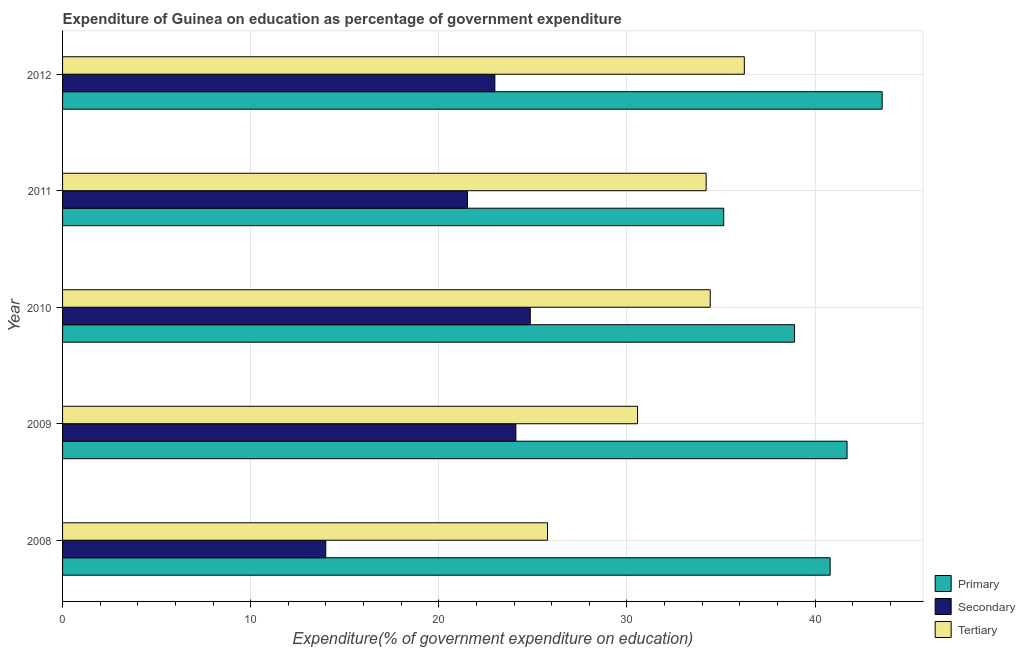Are the number of bars on each tick of the Y-axis equal?
Your response must be concise. Yes. How many bars are there on the 3rd tick from the top?
Keep it short and to the point. 3. How many bars are there on the 5th tick from the bottom?
Provide a succinct answer. 3. In how many cases, is the number of bars for a given year not equal to the number of legend labels?
Your answer should be very brief. 0. What is the expenditure on tertiary education in 2011?
Your response must be concise. 34.21. Across all years, what is the maximum expenditure on secondary education?
Your answer should be compact. 24.86. Across all years, what is the minimum expenditure on secondary education?
Provide a short and direct response. 13.99. In which year was the expenditure on primary education minimum?
Ensure brevity in your answer.  2011. What is the total expenditure on primary education in the graph?
Offer a terse response. 200.1. What is the difference between the expenditure on secondary education in 2009 and that in 2011?
Your answer should be compact. 2.57. What is the difference between the expenditure on tertiary education in 2008 and the expenditure on secondary education in 2010?
Give a very brief answer. 0.92. What is the average expenditure on primary education per year?
Keep it short and to the point. 40.02. In the year 2010, what is the difference between the expenditure on secondary education and expenditure on tertiary education?
Provide a succinct answer. -9.57. What is the ratio of the expenditure on tertiary education in 2008 to that in 2011?
Give a very brief answer. 0.75. Is the expenditure on primary education in 2008 less than that in 2009?
Offer a very short reply. Yes. Is the difference between the expenditure on secondary education in 2008 and 2009 greater than the difference between the expenditure on tertiary education in 2008 and 2009?
Your response must be concise. No. What is the difference between the highest and the second highest expenditure on secondary education?
Provide a short and direct response. 0.76. What is the difference between the highest and the lowest expenditure on tertiary education?
Your answer should be very brief. 10.46. Is the sum of the expenditure on secondary education in 2009 and 2011 greater than the maximum expenditure on primary education across all years?
Your response must be concise. Yes. What does the 1st bar from the top in 2010 represents?
Provide a short and direct response. Tertiary. What does the 2nd bar from the bottom in 2011 represents?
Offer a terse response. Secondary. How many bars are there?
Ensure brevity in your answer.  15. How many years are there in the graph?
Your answer should be very brief. 5. What is the difference between two consecutive major ticks on the X-axis?
Offer a very short reply. 10. Are the values on the major ticks of X-axis written in scientific E-notation?
Your answer should be very brief. No. How are the legend labels stacked?
Keep it short and to the point. Vertical. What is the title of the graph?
Provide a short and direct response. Expenditure of Guinea on education as percentage of government expenditure. What is the label or title of the X-axis?
Offer a very short reply. Expenditure(% of government expenditure on education). What is the Expenditure(% of government expenditure on education) in Primary in 2008?
Provide a succinct answer. 40.8. What is the Expenditure(% of government expenditure on education) of Secondary in 2008?
Offer a terse response. 13.99. What is the Expenditure(% of government expenditure on education) of Tertiary in 2008?
Make the answer very short. 25.78. What is the Expenditure(% of government expenditure on education) of Primary in 2009?
Offer a very short reply. 41.7. What is the Expenditure(% of government expenditure on education) of Secondary in 2009?
Ensure brevity in your answer.  24.09. What is the Expenditure(% of government expenditure on education) in Tertiary in 2009?
Offer a very short reply. 30.56. What is the Expenditure(% of government expenditure on education) in Primary in 2010?
Your answer should be very brief. 38.9. What is the Expenditure(% of government expenditure on education) in Secondary in 2010?
Your answer should be very brief. 24.86. What is the Expenditure(% of government expenditure on education) in Tertiary in 2010?
Offer a terse response. 34.42. What is the Expenditure(% of government expenditure on education) in Primary in 2011?
Your answer should be compact. 35.14. What is the Expenditure(% of government expenditure on education) of Secondary in 2011?
Offer a terse response. 21.52. What is the Expenditure(% of government expenditure on education) of Tertiary in 2011?
Keep it short and to the point. 34.21. What is the Expenditure(% of government expenditure on education) of Primary in 2012?
Offer a terse response. 43.56. What is the Expenditure(% of government expenditure on education) in Secondary in 2012?
Make the answer very short. 22.98. What is the Expenditure(% of government expenditure on education) of Tertiary in 2012?
Offer a very short reply. 36.24. Across all years, what is the maximum Expenditure(% of government expenditure on education) of Primary?
Give a very brief answer. 43.56. Across all years, what is the maximum Expenditure(% of government expenditure on education) in Secondary?
Your response must be concise. 24.86. Across all years, what is the maximum Expenditure(% of government expenditure on education) of Tertiary?
Offer a terse response. 36.24. Across all years, what is the minimum Expenditure(% of government expenditure on education) of Primary?
Offer a very short reply. 35.14. Across all years, what is the minimum Expenditure(% of government expenditure on education) in Secondary?
Offer a very short reply. 13.99. Across all years, what is the minimum Expenditure(% of government expenditure on education) of Tertiary?
Your answer should be compact. 25.78. What is the total Expenditure(% of government expenditure on education) in Primary in the graph?
Give a very brief answer. 200.1. What is the total Expenditure(% of government expenditure on education) in Secondary in the graph?
Your response must be concise. 107.44. What is the total Expenditure(% of government expenditure on education) of Tertiary in the graph?
Offer a very short reply. 161.21. What is the difference between the Expenditure(% of government expenditure on education) of Primary in 2008 and that in 2009?
Ensure brevity in your answer.  -0.9. What is the difference between the Expenditure(% of government expenditure on education) in Secondary in 2008 and that in 2009?
Offer a very short reply. -10.1. What is the difference between the Expenditure(% of government expenditure on education) of Tertiary in 2008 and that in 2009?
Offer a terse response. -4.79. What is the difference between the Expenditure(% of government expenditure on education) in Primary in 2008 and that in 2010?
Provide a succinct answer. 1.89. What is the difference between the Expenditure(% of government expenditure on education) in Secondary in 2008 and that in 2010?
Your response must be concise. -10.87. What is the difference between the Expenditure(% of government expenditure on education) in Tertiary in 2008 and that in 2010?
Offer a terse response. -8.65. What is the difference between the Expenditure(% of government expenditure on education) of Primary in 2008 and that in 2011?
Give a very brief answer. 5.66. What is the difference between the Expenditure(% of government expenditure on education) of Secondary in 2008 and that in 2011?
Provide a short and direct response. -7.53. What is the difference between the Expenditure(% of government expenditure on education) of Tertiary in 2008 and that in 2011?
Ensure brevity in your answer.  -8.43. What is the difference between the Expenditure(% of government expenditure on education) in Primary in 2008 and that in 2012?
Your response must be concise. -2.77. What is the difference between the Expenditure(% of government expenditure on education) of Secondary in 2008 and that in 2012?
Make the answer very short. -8.99. What is the difference between the Expenditure(% of government expenditure on education) in Tertiary in 2008 and that in 2012?
Provide a short and direct response. -10.46. What is the difference between the Expenditure(% of government expenditure on education) in Primary in 2009 and that in 2010?
Ensure brevity in your answer.  2.79. What is the difference between the Expenditure(% of government expenditure on education) of Secondary in 2009 and that in 2010?
Your answer should be compact. -0.76. What is the difference between the Expenditure(% of government expenditure on education) of Tertiary in 2009 and that in 2010?
Ensure brevity in your answer.  -3.86. What is the difference between the Expenditure(% of government expenditure on education) of Primary in 2009 and that in 2011?
Give a very brief answer. 6.56. What is the difference between the Expenditure(% of government expenditure on education) of Secondary in 2009 and that in 2011?
Make the answer very short. 2.57. What is the difference between the Expenditure(% of government expenditure on education) of Tertiary in 2009 and that in 2011?
Offer a very short reply. -3.65. What is the difference between the Expenditure(% of government expenditure on education) of Primary in 2009 and that in 2012?
Provide a succinct answer. -1.87. What is the difference between the Expenditure(% of government expenditure on education) in Secondary in 2009 and that in 2012?
Your answer should be very brief. 1.12. What is the difference between the Expenditure(% of government expenditure on education) in Tertiary in 2009 and that in 2012?
Offer a terse response. -5.68. What is the difference between the Expenditure(% of government expenditure on education) of Primary in 2010 and that in 2011?
Your answer should be compact. 3.76. What is the difference between the Expenditure(% of government expenditure on education) in Secondary in 2010 and that in 2011?
Your answer should be compact. 3.33. What is the difference between the Expenditure(% of government expenditure on education) in Tertiary in 2010 and that in 2011?
Make the answer very short. 0.22. What is the difference between the Expenditure(% of government expenditure on education) of Primary in 2010 and that in 2012?
Your response must be concise. -4.66. What is the difference between the Expenditure(% of government expenditure on education) in Secondary in 2010 and that in 2012?
Ensure brevity in your answer.  1.88. What is the difference between the Expenditure(% of government expenditure on education) in Tertiary in 2010 and that in 2012?
Make the answer very short. -1.81. What is the difference between the Expenditure(% of government expenditure on education) of Primary in 2011 and that in 2012?
Offer a very short reply. -8.42. What is the difference between the Expenditure(% of government expenditure on education) of Secondary in 2011 and that in 2012?
Your answer should be compact. -1.45. What is the difference between the Expenditure(% of government expenditure on education) of Tertiary in 2011 and that in 2012?
Your response must be concise. -2.03. What is the difference between the Expenditure(% of government expenditure on education) in Primary in 2008 and the Expenditure(% of government expenditure on education) in Secondary in 2009?
Provide a succinct answer. 16.7. What is the difference between the Expenditure(% of government expenditure on education) in Primary in 2008 and the Expenditure(% of government expenditure on education) in Tertiary in 2009?
Keep it short and to the point. 10.24. What is the difference between the Expenditure(% of government expenditure on education) in Secondary in 2008 and the Expenditure(% of government expenditure on education) in Tertiary in 2009?
Your answer should be compact. -16.57. What is the difference between the Expenditure(% of government expenditure on education) in Primary in 2008 and the Expenditure(% of government expenditure on education) in Secondary in 2010?
Your response must be concise. 15.94. What is the difference between the Expenditure(% of government expenditure on education) in Primary in 2008 and the Expenditure(% of government expenditure on education) in Tertiary in 2010?
Make the answer very short. 6.37. What is the difference between the Expenditure(% of government expenditure on education) of Secondary in 2008 and the Expenditure(% of government expenditure on education) of Tertiary in 2010?
Provide a succinct answer. -20.43. What is the difference between the Expenditure(% of government expenditure on education) in Primary in 2008 and the Expenditure(% of government expenditure on education) in Secondary in 2011?
Offer a very short reply. 19.27. What is the difference between the Expenditure(% of government expenditure on education) of Primary in 2008 and the Expenditure(% of government expenditure on education) of Tertiary in 2011?
Your response must be concise. 6.59. What is the difference between the Expenditure(% of government expenditure on education) of Secondary in 2008 and the Expenditure(% of government expenditure on education) of Tertiary in 2011?
Provide a short and direct response. -20.22. What is the difference between the Expenditure(% of government expenditure on education) in Primary in 2008 and the Expenditure(% of government expenditure on education) in Secondary in 2012?
Keep it short and to the point. 17.82. What is the difference between the Expenditure(% of government expenditure on education) of Primary in 2008 and the Expenditure(% of government expenditure on education) of Tertiary in 2012?
Provide a succinct answer. 4.56. What is the difference between the Expenditure(% of government expenditure on education) of Secondary in 2008 and the Expenditure(% of government expenditure on education) of Tertiary in 2012?
Your answer should be compact. -22.25. What is the difference between the Expenditure(% of government expenditure on education) of Primary in 2009 and the Expenditure(% of government expenditure on education) of Secondary in 2010?
Keep it short and to the point. 16.84. What is the difference between the Expenditure(% of government expenditure on education) of Primary in 2009 and the Expenditure(% of government expenditure on education) of Tertiary in 2010?
Your answer should be very brief. 7.27. What is the difference between the Expenditure(% of government expenditure on education) of Secondary in 2009 and the Expenditure(% of government expenditure on education) of Tertiary in 2010?
Ensure brevity in your answer.  -10.33. What is the difference between the Expenditure(% of government expenditure on education) of Primary in 2009 and the Expenditure(% of government expenditure on education) of Secondary in 2011?
Ensure brevity in your answer.  20.17. What is the difference between the Expenditure(% of government expenditure on education) of Primary in 2009 and the Expenditure(% of government expenditure on education) of Tertiary in 2011?
Ensure brevity in your answer.  7.49. What is the difference between the Expenditure(% of government expenditure on education) in Secondary in 2009 and the Expenditure(% of government expenditure on education) in Tertiary in 2011?
Provide a succinct answer. -10.11. What is the difference between the Expenditure(% of government expenditure on education) of Primary in 2009 and the Expenditure(% of government expenditure on education) of Secondary in 2012?
Your answer should be compact. 18.72. What is the difference between the Expenditure(% of government expenditure on education) in Primary in 2009 and the Expenditure(% of government expenditure on education) in Tertiary in 2012?
Your response must be concise. 5.46. What is the difference between the Expenditure(% of government expenditure on education) of Secondary in 2009 and the Expenditure(% of government expenditure on education) of Tertiary in 2012?
Ensure brevity in your answer.  -12.14. What is the difference between the Expenditure(% of government expenditure on education) in Primary in 2010 and the Expenditure(% of government expenditure on education) in Secondary in 2011?
Make the answer very short. 17.38. What is the difference between the Expenditure(% of government expenditure on education) in Primary in 2010 and the Expenditure(% of government expenditure on education) in Tertiary in 2011?
Your answer should be very brief. 4.7. What is the difference between the Expenditure(% of government expenditure on education) of Secondary in 2010 and the Expenditure(% of government expenditure on education) of Tertiary in 2011?
Keep it short and to the point. -9.35. What is the difference between the Expenditure(% of government expenditure on education) in Primary in 2010 and the Expenditure(% of government expenditure on education) in Secondary in 2012?
Your answer should be compact. 15.93. What is the difference between the Expenditure(% of government expenditure on education) in Primary in 2010 and the Expenditure(% of government expenditure on education) in Tertiary in 2012?
Your answer should be very brief. 2.67. What is the difference between the Expenditure(% of government expenditure on education) in Secondary in 2010 and the Expenditure(% of government expenditure on education) in Tertiary in 2012?
Offer a terse response. -11.38. What is the difference between the Expenditure(% of government expenditure on education) of Primary in 2011 and the Expenditure(% of government expenditure on education) of Secondary in 2012?
Make the answer very short. 12.16. What is the difference between the Expenditure(% of government expenditure on education) of Primary in 2011 and the Expenditure(% of government expenditure on education) of Tertiary in 2012?
Give a very brief answer. -1.1. What is the difference between the Expenditure(% of government expenditure on education) in Secondary in 2011 and the Expenditure(% of government expenditure on education) in Tertiary in 2012?
Keep it short and to the point. -14.71. What is the average Expenditure(% of government expenditure on education) in Primary per year?
Make the answer very short. 40.02. What is the average Expenditure(% of government expenditure on education) of Secondary per year?
Keep it short and to the point. 21.49. What is the average Expenditure(% of government expenditure on education) in Tertiary per year?
Offer a very short reply. 32.24. In the year 2008, what is the difference between the Expenditure(% of government expenditure on education) of Primary and Expenditure(% of government expenditure on education) of Secondary?
Your answer should be compact. 26.81. In the year 2008, what is the difference between the Expenditure(% of government expenditure on education) in Primary and Expenditure(% of government expenditure on education) in Tertiary?
Make the answer very short. 15.02. In the year 2008, what is the difference between the Expenditure(% of government expenditure on education) in Secondary and Expenditure(% of government expenditure on education) in Tertiary?
Give a very brief answer. -11.79. In the year 2009, what is the difference between the Expenditure(% of government expenditure on education) in Primary and Expenditure(% of government expenditure on education) in Secondary?
Keep it short and to the point. 17.6. In the year 2009, what is the difference between the Expenditure(% of government expenditure on education) of Primary and Expenditure(% of government expenditure on education) of Tertiary?
Offer a terse response. 11.14. In the year 2009, what is the difference between the Expenditure(% of government expenditure on education) of Secondary and Expenditure(% of government expenditure on education) of Tertiary?
Your response must be concise. -6.47. In the year 2010, what is the difference between the Expenditure(% of government expenditure on education) of Primary and Expenditure(% of government expenditure on education) of Secondary?
Your answer should be compact. 14.05. In the year 2010, what is the difference between the Expenditure(% of government expenditure on education) in Primary and Expenditure(% of government expenditure on education) in Tertiary?
Your answer should be very brief. 4.48. In the year 2010, what is the difference between the Expenditure(% of government expenditure on education) in Secondary and Expenditure(% of government expenditure on education) in Tertiary?
Your answer should be very brief. -9.57. In the year 2011, what is the difference between the Expenditure(% of government expenditure on education) of Primary and Expenditure(% of government expenditure on education) of Secondary?
Offer a very short reply. 13.62. In the year 2011, what is the difference between the Expenditure(% of government expenditure on education) in Primary and Expenditure(% of government expenditure on education) in Tertiary?
Provide a succinct answer. 0.93. In the year 2011, what is the difference between the Expenditure(% of government expenditure on education) in Secondary and Expenditure(% of government expenditure on education) in Tertiary?
Give a very brief answer. -12.69. In the year 2012, what is the difference between the Expenditure(% of government expenditure on education) in Primary and Expenditure(% of government expenditure on education) in Secondary?
Give a very brief answer. 20.59. In the year 2012, what is the difference between the Expenditure(% of government expenditure on education) in Primary and Expenditure(% of government expenditure on education) in Tertiary?
Offer a terse response. 7.33. In the year 2012, what is the difference between the Expenditure(% of government expenditure on education) of Secondary and Expenditure(% of government expenditure on education) of Tertiary?
Give a very brief answer. -13.26. What is the ratio of the Expenditure(% of government expenditure on education) of Primary in 2008 to that in 2009?
Make the answer very short. 0.98. What is the ratio of the Expenditure(% of government expenditure on education) of Secondary in 2008 to that in 2009?
Offer a terse response. 0.58. What is the ratio of the Expenditure(% of government expenditure on education) in Tertiary in 2008 to that in 2009?
Make the answer very short. 0.84. What is the ratio of the Expenditure(% of government expenditure on education) of Primary in 2008 to that in 2010?
Offer a terse response. 1.05. What is the ratio of the Expenditure(% of government expenditure on education) of Secondary in 2008 to that in 2010?
Provide a succinct answer. 0.56. What is the ratio of the Expenditure(% of government expenditure on education) of Tertiary in 2008 to that in 2010?
Ensure brevity in your answer.  0.75. What is the ratio of the Expenditure(% of government expenditure on education) of Primary in 2008 to that in 2011?
Ensure brevity in your answer.  1.16. What is the ratio of the Expenditure(% of government expenditure on education) of Secondary in 2008 to that in 2011?
Keep it short and to the point. 0.65. What is the ratio of the Expenditure(% of government expenditure on education) of Tertiary in 2008 to that in 2011?
Make the answer very short. 0.75. What is the ratio of the Expenditure(% of government expenditure on education) of Primary in 2008 to that in 2012?
Ensure brevity in your answer.  0.94. What is the ratio of the Expenditure(% of government expenditure on education) in Secondary in 2008 to that in 2012?
Your answer should be compact. 0.61. What is the ratio of the Expenditure(% of government expenditure on education) of Tertiary in 2008 to that in 2012?
Ensure brevity in your answer.  0.71. What is the ratio of the Expenditure(% of government expenditure on education) in Primary in 2009 to that in 2010?
Provide a succinct answer. 1.07. What is the ratio of the Expenditure(% of government expenditure on education) of Secondary in 2009 to that in 2010?
Your response must be concise. 0.97. What is the ratio of the Expenditure(% of government expenditure on education) of Tertiary in 2009 to that in 2010?
Ensure brevity in your answer.  0.89. What is the ratio of the Expenditure(% of government expenditure on education) of Primary in 2009 to that in 2011?
Your answer should be very brief. 1.19. What is the ratio of the Expenditure(% of government expenditure on education) of Secondary in 2009 to that in 2011?
Give a very brief answer. 1.12. What is the ratio of the Expenditure(% of government expenditure on education) of Tertiary in 2009 to that in 2011?
Your response must be concise. 0.89. What is the ratio of the Expenditure(% of government expenditure on education) of Primary in 2009 to that in 2012?
Ensure brevity in your answer.  0.96. What is the ratio of the Expenditure(% of government expenditure on education) of Secondary in 2009 to that in 2012?
Your answer should be very brief. 1.05. What is the ratio of the Expenditure(% of government expenditure on education) of Tertiary in 2009 to that in 2012?
Offer a terse response. 0.84. What is the ratio of the Expenditure(% of government expenditure on education) in Primary in 2010 to that in 2011?
Keep it short and to the point. 1.11. What is the ratio of the Expenditure(% of government expenditure on education) of Secondary in 2010 to that in 2011?
Provide a succinct answer. 1.15. What is the ratio of the Expenditure(% of government expenditure on education) of Primary in 2010 to that in 2012?
Offer a very short reply. 0.89. What is the ratio of the Expenditure(% of government expenditure on education) of Secondary in 2010 to that in 2012?
Keep it short and to the point. 1.08. What is the ratio of the Expenditure(% of government expenditure on education) in Primary in 2011 to that in 2012?
Ensure brevity in your answer.  0.81. What is the ratio of the Expenditure(% of government expenditure on education) in Secondary in 2011 to that in 2012?
Provide a succinct answer. 0.94. What is the ratio of the Expenditure(% of government expenditure on education) of Tertiary in 2011 to that in 2012?
Your answer should be compact. 0.94. What is the difference between the highest and the second highest Expenditure(% of government expenditure on education) of Primary?
Offer a very short reply. 1.87. What is the difference between the highest and the second highest Expenditure(% of government expenditure on education) of Secondary?
Keep it short and to the point. 0.76. What is the difference between the highest and the second highest Expenditure(% of government expenditure on education) in Tertiary?
Your answer should be very brief. 1.81. What is the difference between the highest and the lowest Expenditure(% of government expenditure on education) of Primary?
Your response must be concise. 8.42. What is the difference between the highest and the lowest Expenditure(% of government expenditure on education) in Secondary?
Make the answer very short. 10.87. What is the difference between the highest and the lowest Expenditure(% of government expenditure on education) in Tertiary?
Ensure brevity in your answer.  10.46. 